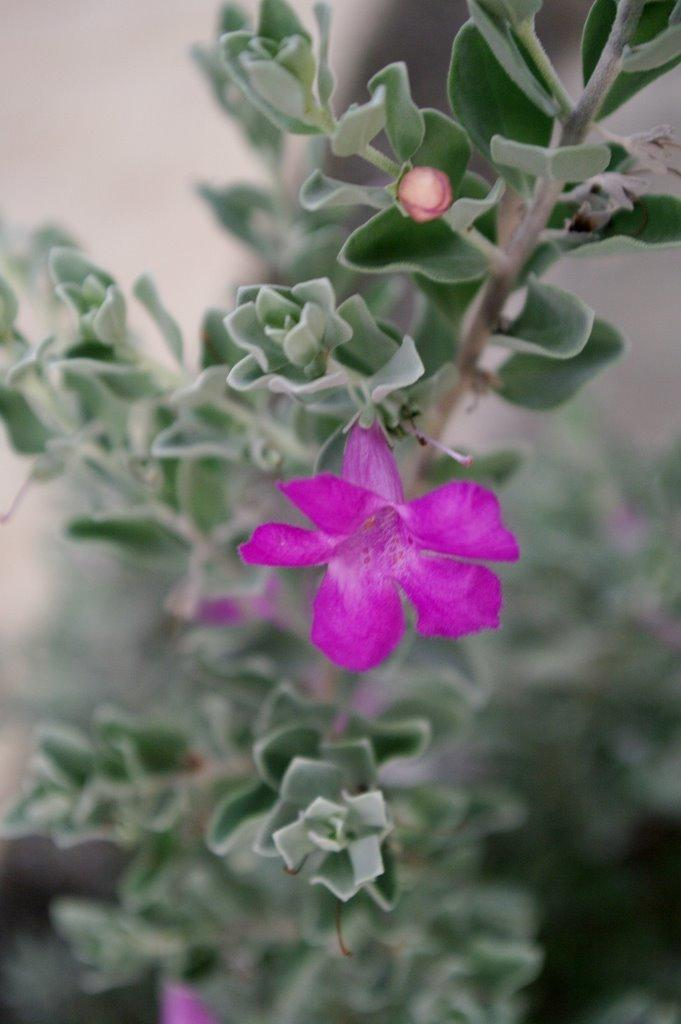What color is the flower in the image? The flower in the image is pink. What is the flower a part of? The flower is part of a plant. What color are the leaves of the plant? The leaves of the plant are green. Can you describe the background of the image? The background of the image is blurred. How many goats can be seen grazing in the background of the image? There are no goats present in the image; the background is blurred. What type of clouds are visible in the image? There are no clouds visible in the image, as the background is blurred. 